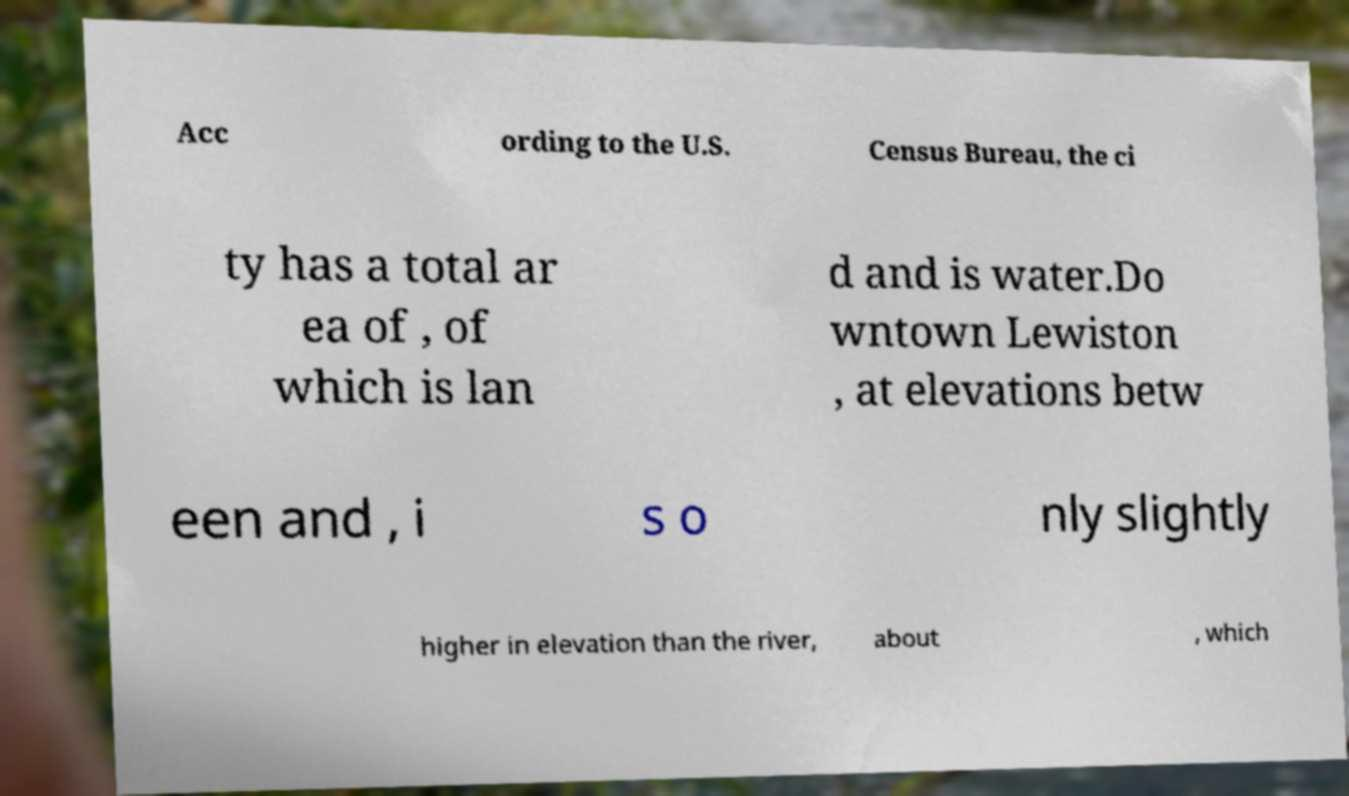There's text embedded in this image that I need extracted. Can you transcribe it verbatim? Acc ording to the U.S. Census Bureau, the ci ty has a total ar ea of , of which is lan d and is water.Do wntown Lewiston , at elevations betw een and , i s o nly slightly higher in elevation than the river, about , which 